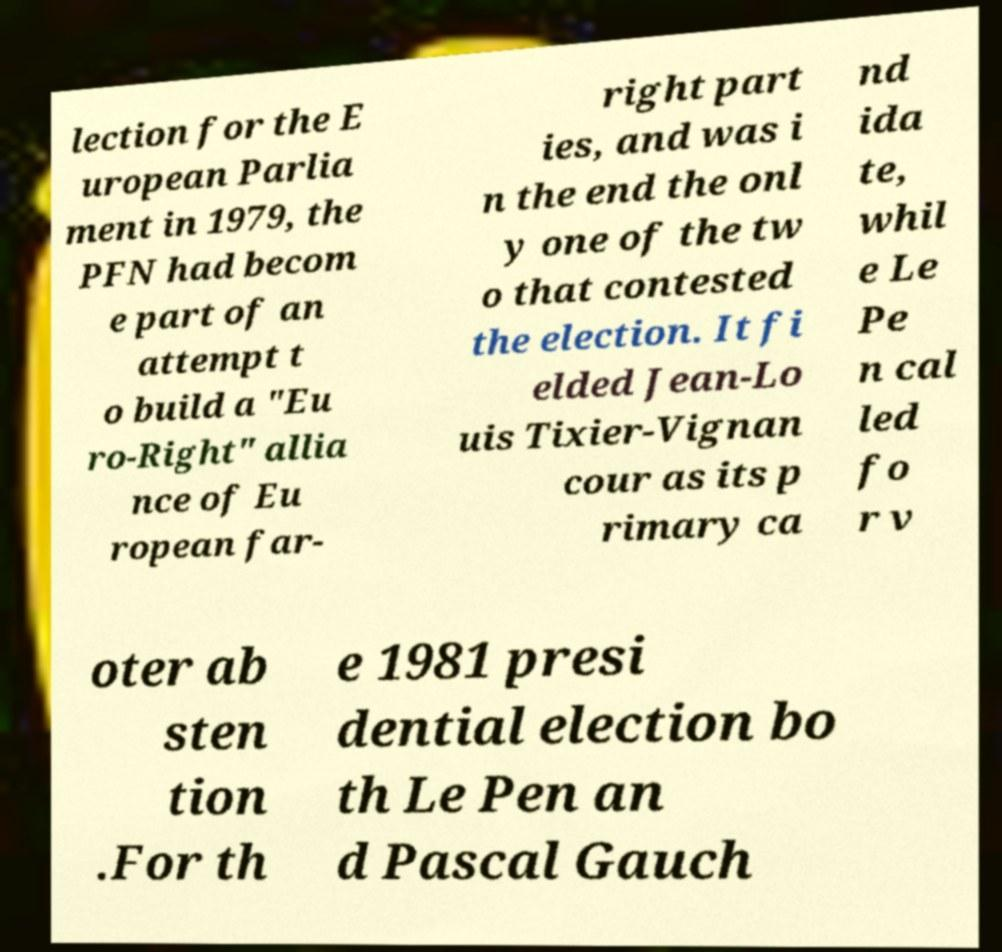I need the written content from this picture converted into text. Can you do that? lection for the E uropean Parlia ment in 1979, the PFN had becom e part of an attempt t o build a "Eu ro-Right" allia nce of Eu ropean far- right part ies, and was i n the end the onl y one of the tw o that contested the election. It fi elded Jean-Lo uis Tixier-Vignan cour as its p rimary ca nd ida te, whil e Le Pe n cal led fo r v oter ab sten tion .For th e 1981 presi dential election bo th Le Pen an d Pascal Gauch 